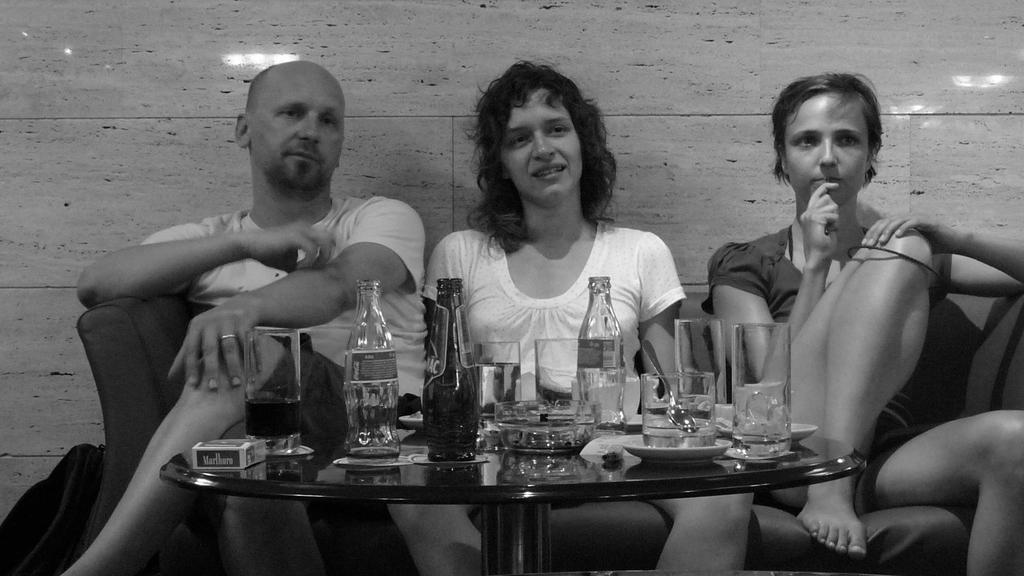How many people are in the image? There are three people in the image. What are the people doing in the image? The people are seated on a sofa. What objects are on the table in the image? There are bottles, glasses, and plates on the table. What type of stem can be seen growing from the sofa in the image? There is no stem growing from the sofa in the image. What is the father doing in the image? The image does not specify any relationships between the people, so we cannot determine who the father is. 